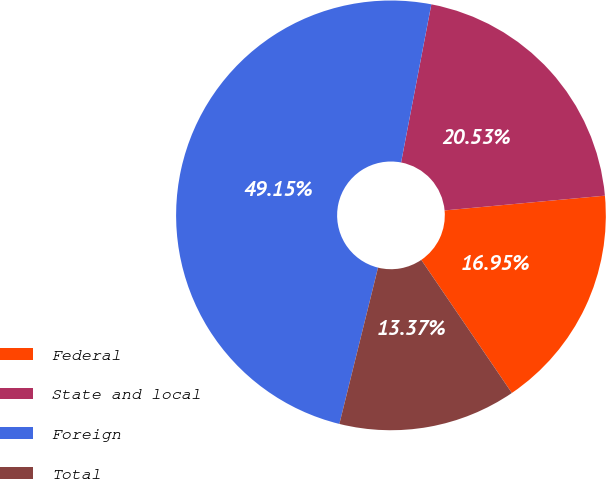Convert chart. <chart><loc_0><loc_0><loc_500><loc_500><pie_chart><fcel>Federal<fcel>State and local<fcel>Foreign<fcel>Total<nl><fcel>16.95%<fcel>20.53%<fcel>49.15%<fcel>13.37%<nl></chart> 